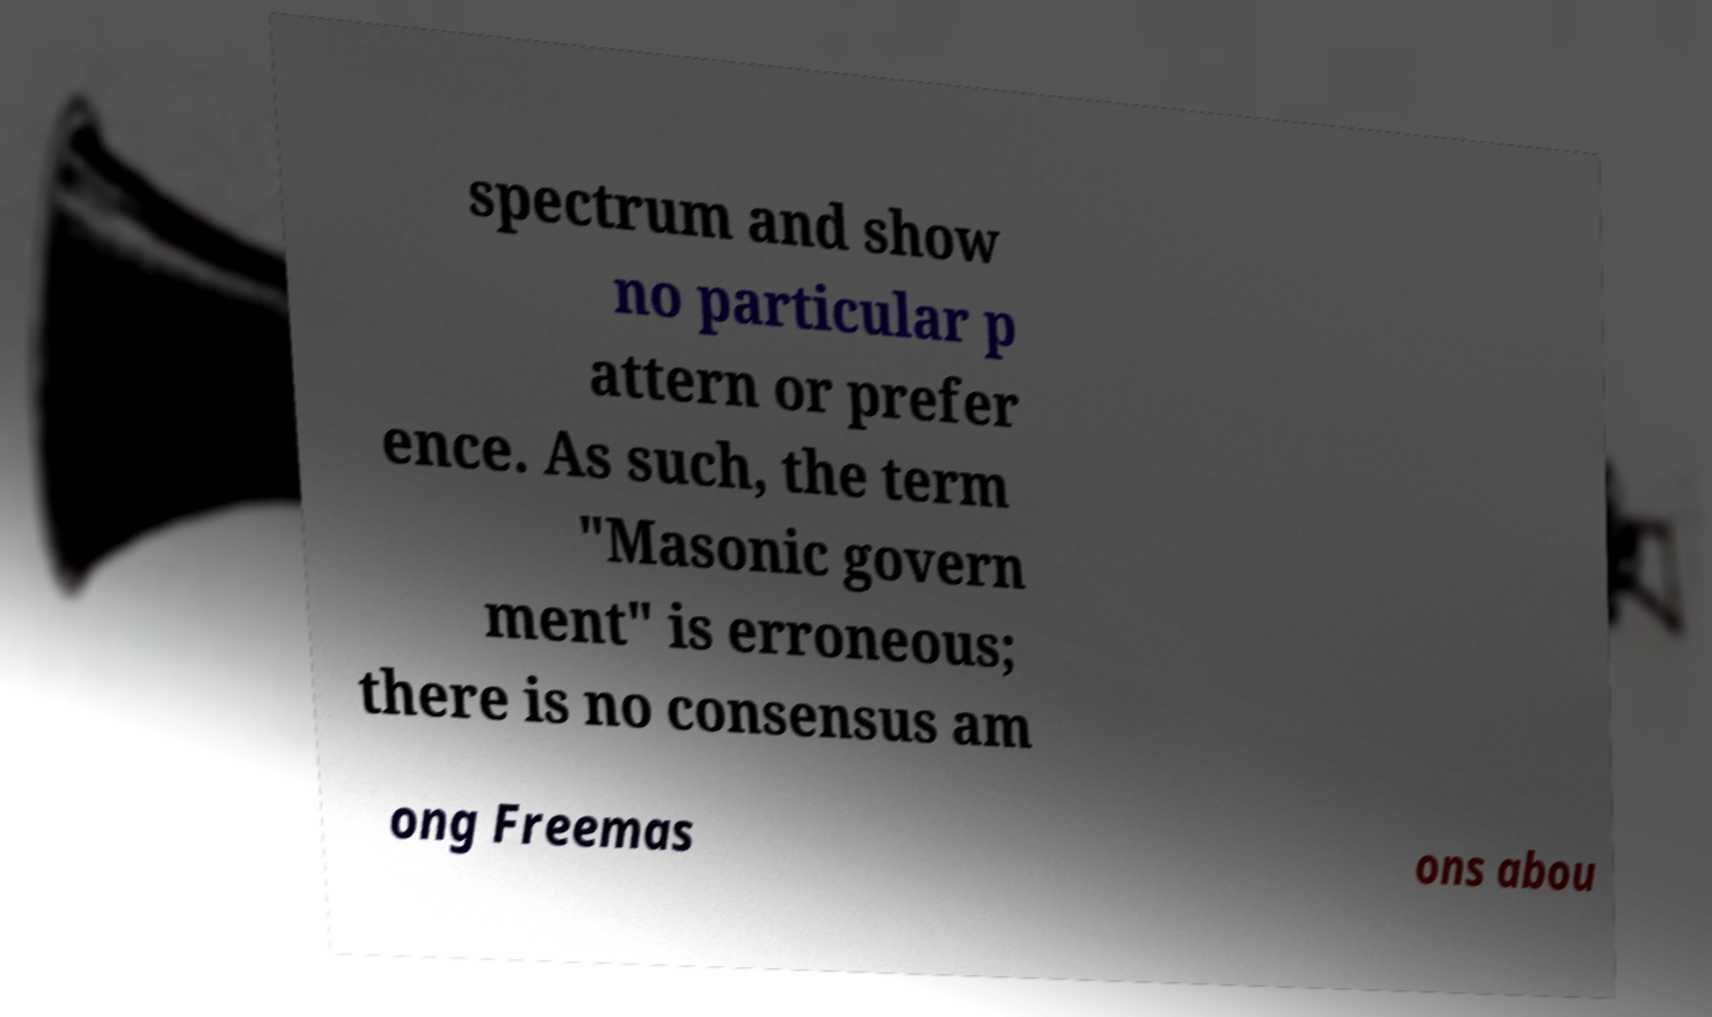Please identify and transcribe the text found in this image. spectrum and show no particular p attern or prefer ence. As such, the term "Masonic govern ment" is erroneous; there is no consensus am ong Freemas ons abou 